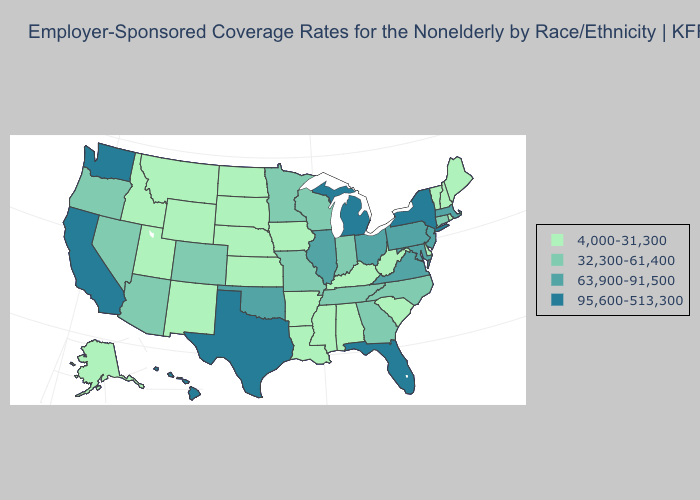How many symbols are there in the legend?
Answer briefly. 4. Name the states that have a value in the range 4,000-31,300?
Write a very short answer. Alabama, Alaska, Arkansas, Delaware, Idaho, Iowa, Kansas, Kentucky, Louisiana, Maine, Mississippi, Montana, Nebraska, New Hampshire, New Mexico, North Dakota, Rhode Island, South Carolina, South Dakota, Utah, Vermont, West Virginia, Wyoming. Which states have the lowest value in the USA?
Write a very short answer. Alabama, Alaska, Arkansas, Delaware, Idaho, Iowa, Kansas, Kentucky, Louisiana, Maine, Mississippi, Montana, Nebraska, New Hampshire, New Mexico, North Dakota, Rhode Island, South Carolina, South Dakota, Utah, Vermont, West Virginia, Wyoming. Does Arkansas have a lower value than Vermont?
Write a very short answer. No. What is the highest value in the South ?
Write a very short answer. 95,600-513,300. Among the states that border Wyoming , which have the highest value?
Be succinct. Colorado. Name the states that have a value in the range 32,300-61,400?
Concise answer only. Arizona, Colorado, Connecticut, Georgia, Indiana, Minnesota, Missouri, Nevada, North Carolina, Oregon, Tennessee, Wisconsin. Does North Carolina have the lowest value in the South?
Write a very short answer. No. Is the legend a continuous bar?
Keep it brief. No. Name the states that have a value in the range 4,000-31,300?
Keep it brief. Alabama, Alaska, Arkansas, Delaware, Idaho, Iowa, Kansas, Kentucky, Louisiana, Maine, Mississippi, Montana, Nebraska, New Hampshire, New Mexico, North Dakota, Rhode Island, South Carolina, South Dakota, Utah, Vermont, West Virginia, Wyoming. What is the value of Idaho?
Give a very brief answer. 4,000-31,300. What is the value of Minnesota?
Give a very brief answer. 32,300-61,400. Name the states that have a value in the range 4,000-31,300?
Quick response, please. Alabama, Alaska, Arkansas, Delaware, Idaho, Iowa, Kansas, Kentucky, Louisiana, Maine, Mississippi, Montana, Nebraska, New Hampshire, New Mexico, North Dakota, Rhode Island, South Carolina, South Dakota, Utah, Vermont, West Virginia, Wyoming. What is the highest value in states that border Kentucky?
Short answer required. 63,900-91,500. What is the value of Ohio?
Be succinct. 63,900-91,500. 